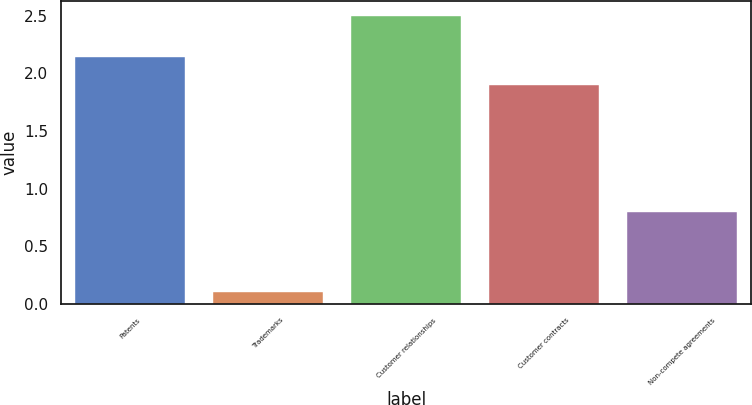<chart> <loc_0><loc_0><loc_500><loc_500><bar_chart><fcel>Patents<fcel>Trademarks<fcel>Customer relationships<fcel>Customer contracts<fcel>Non-compete agreements<nl><fcel>2.14<fcel>0.1<fcel>2.5<fcel>1.9<fcel>0.8<nl></chart> 